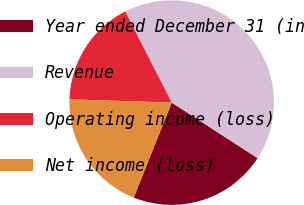Convert chart to OTSL. <chart><loc_0><loc_0><loc_500><loc_500><pie_chart><fcel>Year ended December 31 (in<fcel>Revenue<fcel>Operating income (loss)<fcel>Net income (loss)<nl><fcel>21.92%<fcel>41.64%<fcel>16.99%<fcel>19.45%<nl></chart> 